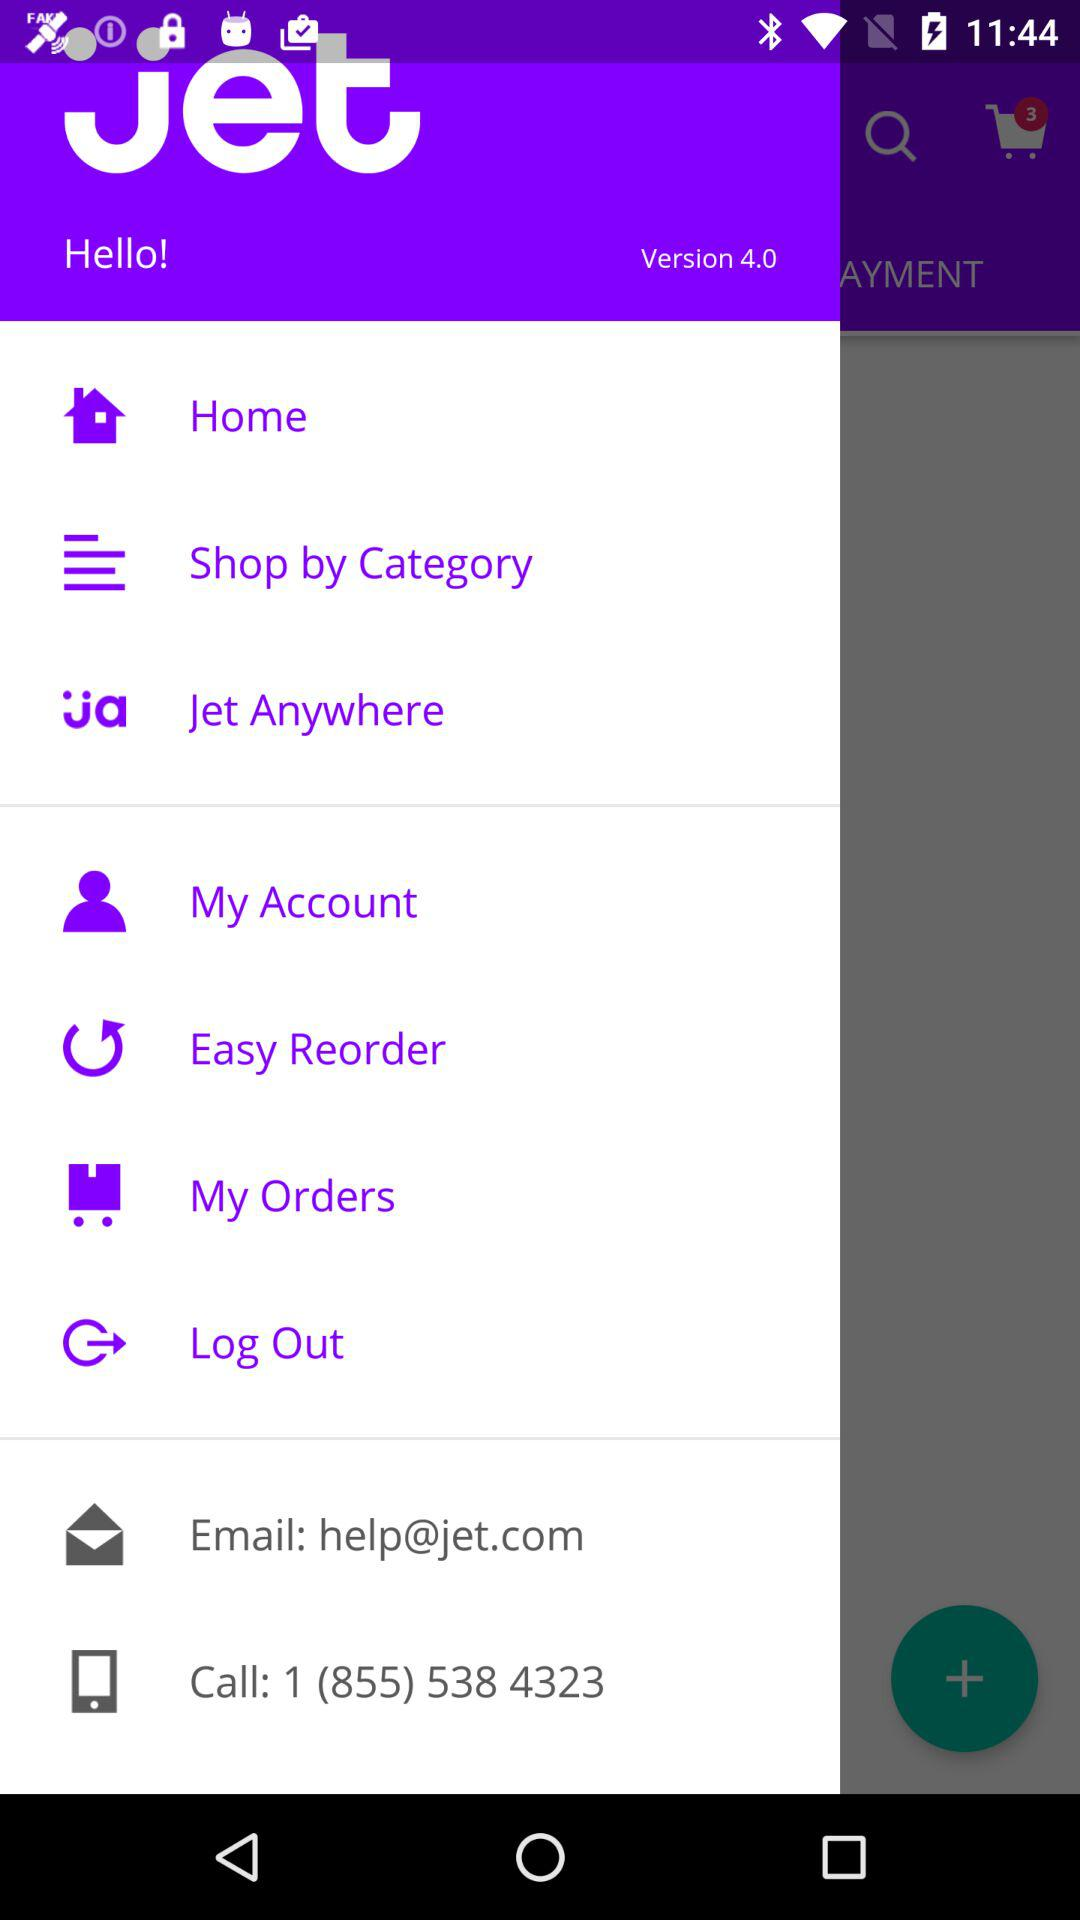What is the contact number? The contact number is 1 (855) 538 4323. 